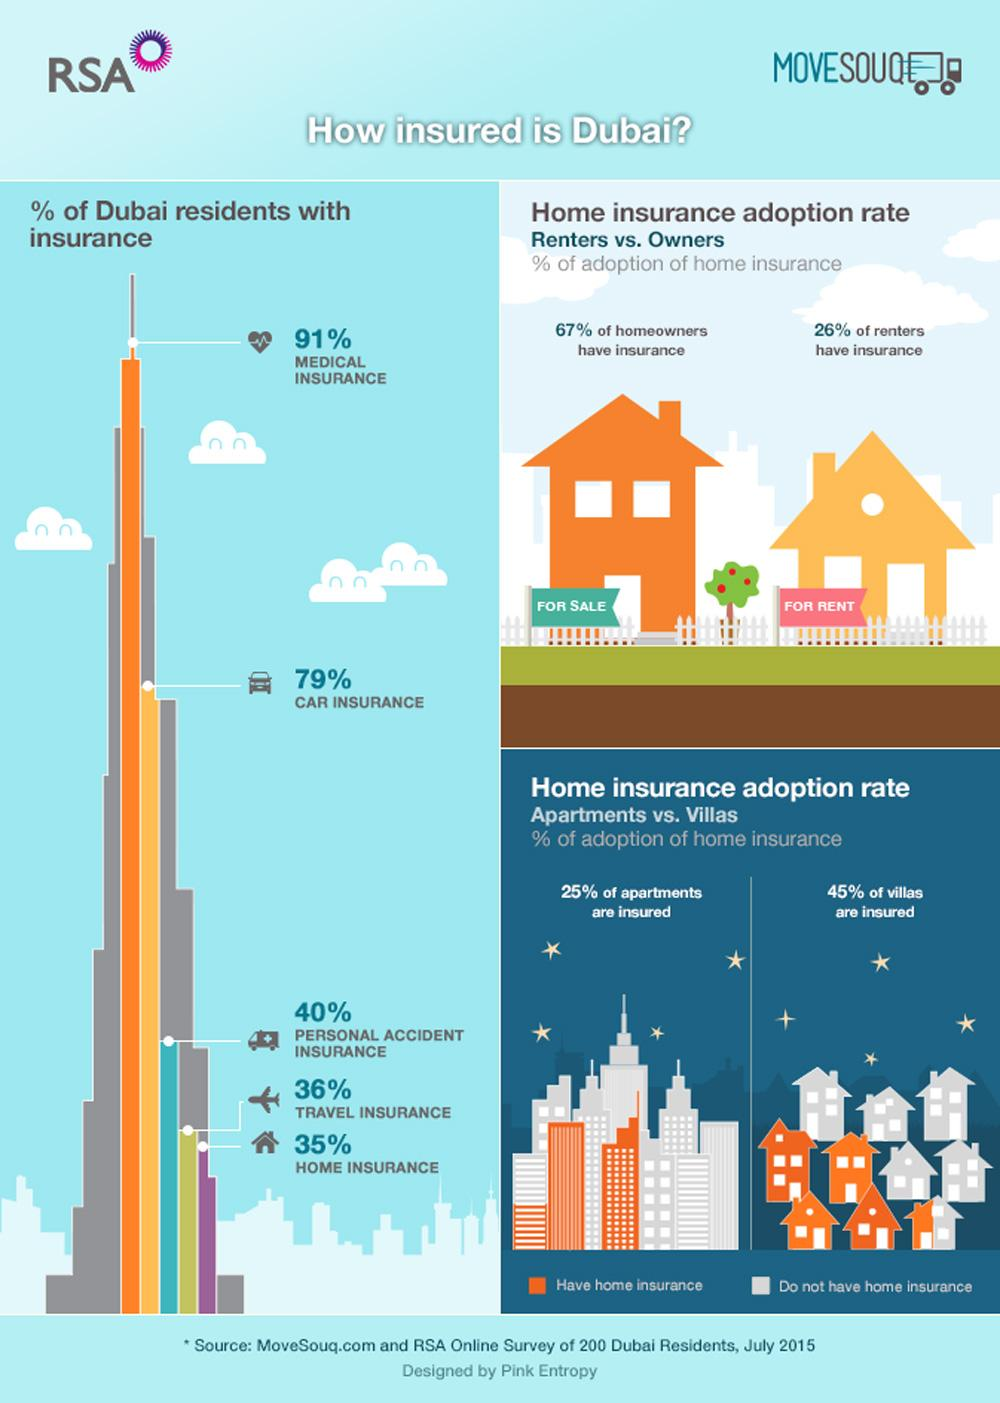Identify some key points in this picture. According to a recent survey, 26% of individuals who do not reside in their own homes have obtained insurance coverage. According to a recent survey, a significant percentage of people living in Dubai do not have car insurance. Specifically, 21% of the population does not have this important coverage. According to a recent survey, approximately 65% of the population in Dubai does not have home insurance. Car insurance has the second highest rank among other types of insurance. According to recent studies, approximately 40% of people living in Dubai have injury insurance coverage. 